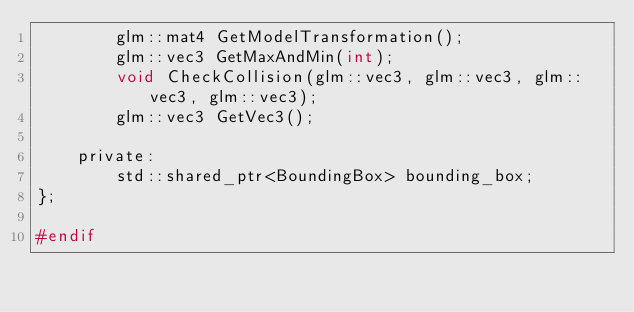Convert code to text. <code><loc_0><loc_0><loc_500><loc_500><_C_>		glm::mat4 GetModelTransformation();
		glm::vec3 GetMaxAndMin(int);
		void CheckCollision(glm::vec3, glm::vec3, glm::vec3, glm::vec3);
		glm::vec3 GetVec3();

	private:
		std::shared_ptr<BoundingBox> bounding_box;
};

#endif
</code> 